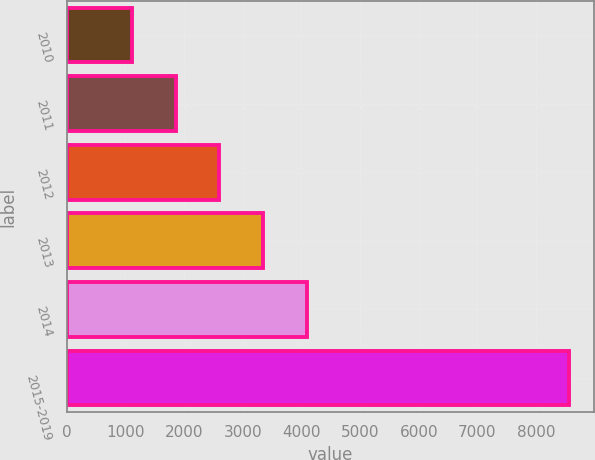<chart> <loc_0><loc_0><loc_500><loc_500><bar_chart><fcel>2010<fcel>2011<fcel>2012<fcel>2013<fcel>2014<fcel>2015-2019<nl><fcel>1114<fcel>1857.8<fcel>2601.6<fcel>3345.4<fcel>4089.2<fcel>8552<nl></chart> 